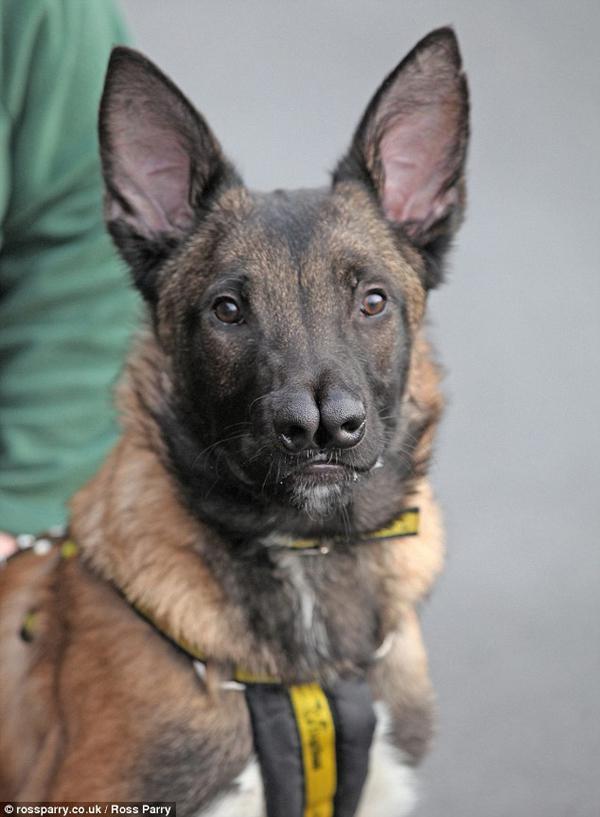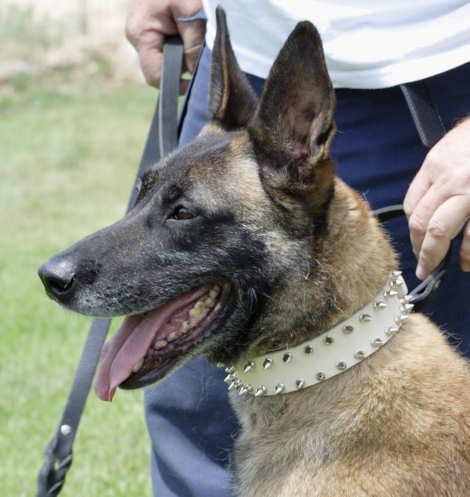The first image is the image on the left, the second image is the image on the right. Given the left and right images, does the statement "A dog is lying on the cement in one of the images." hold true? Answer yes or no. No. The first image is the image on the left, the second image is the image on the right. Assess this claim about the two images: "No human is visible next to the german shepherd dog in the right image.". Correct or not? Answer yes or no. No. 